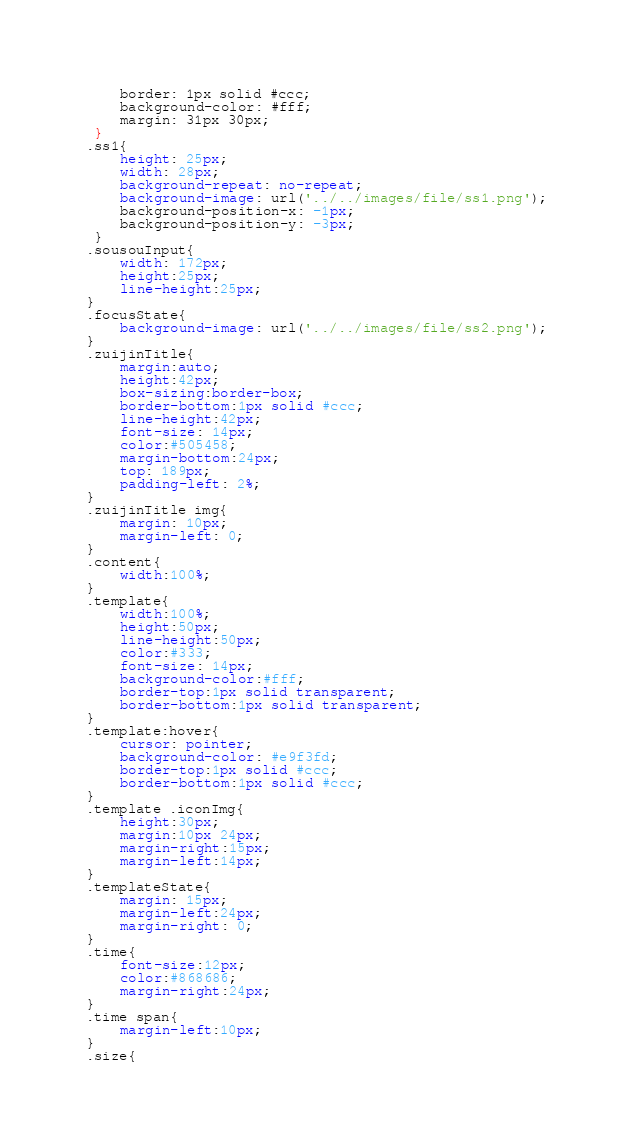<code> <loc_0><loc_0><loc_500><loc_500><_CSS_>    border: 1px solid #ccc;
    background-color: #fff;
    margin: 31px 30px;
 }
.ss1{
    height: 25px;
    width: 28px;
    background-repeat: no-repeat;
    background-image: url('../../images/file/ss1.png');
    background-position-x: -1px;
    background-position-y: -3px;
 }
.sousouInput{
    width: 172px;
    height:25px;
    line-height:25px;
}
.focusState{
    background-image: url('../../images/file/ss2.png');
}
.zuijinTitle{
    margin:auto;
    height:42px;
    box-sizing:border-box;
    border-bottom:1px solid #ccc;
    line-height:42px;
    font-size: 14px;
    color:#505458;
    margin-bottom:24px;
    top: 189px;
    padding-left: 2%;
}
.zuijinTitle img{
    margin: 10px;
    margin-left: 0;
}
.content{
    width:100%;
}
.template{
    width:100%;
    height:50px;
    line-height:50px;
    color:#333;
    font-size: 14px;
    background-color:#fff;
    border-top:1px solid transparent;
    border-bottom:1px solid transparent;
}
.template:hover{
    cursor: pointer;
    background-color: #e9f3fd;
    border-top:1px solid #ccc;
    border-bottom:1px solid #ccc;
}
.template .iconImg{
    height:30px;
    margin:10px 24px;
    margin-right:15px;
    margin-left:14px;
}
.templateState{
    margin: 15px;
    margin-left:24px;
    margin-right: 0;
}
.time{
    font-size:12px;
    color:#868686;
    margin-right:24px;
}
.time span{
    margin-left:10px;
}
.size{</code> 